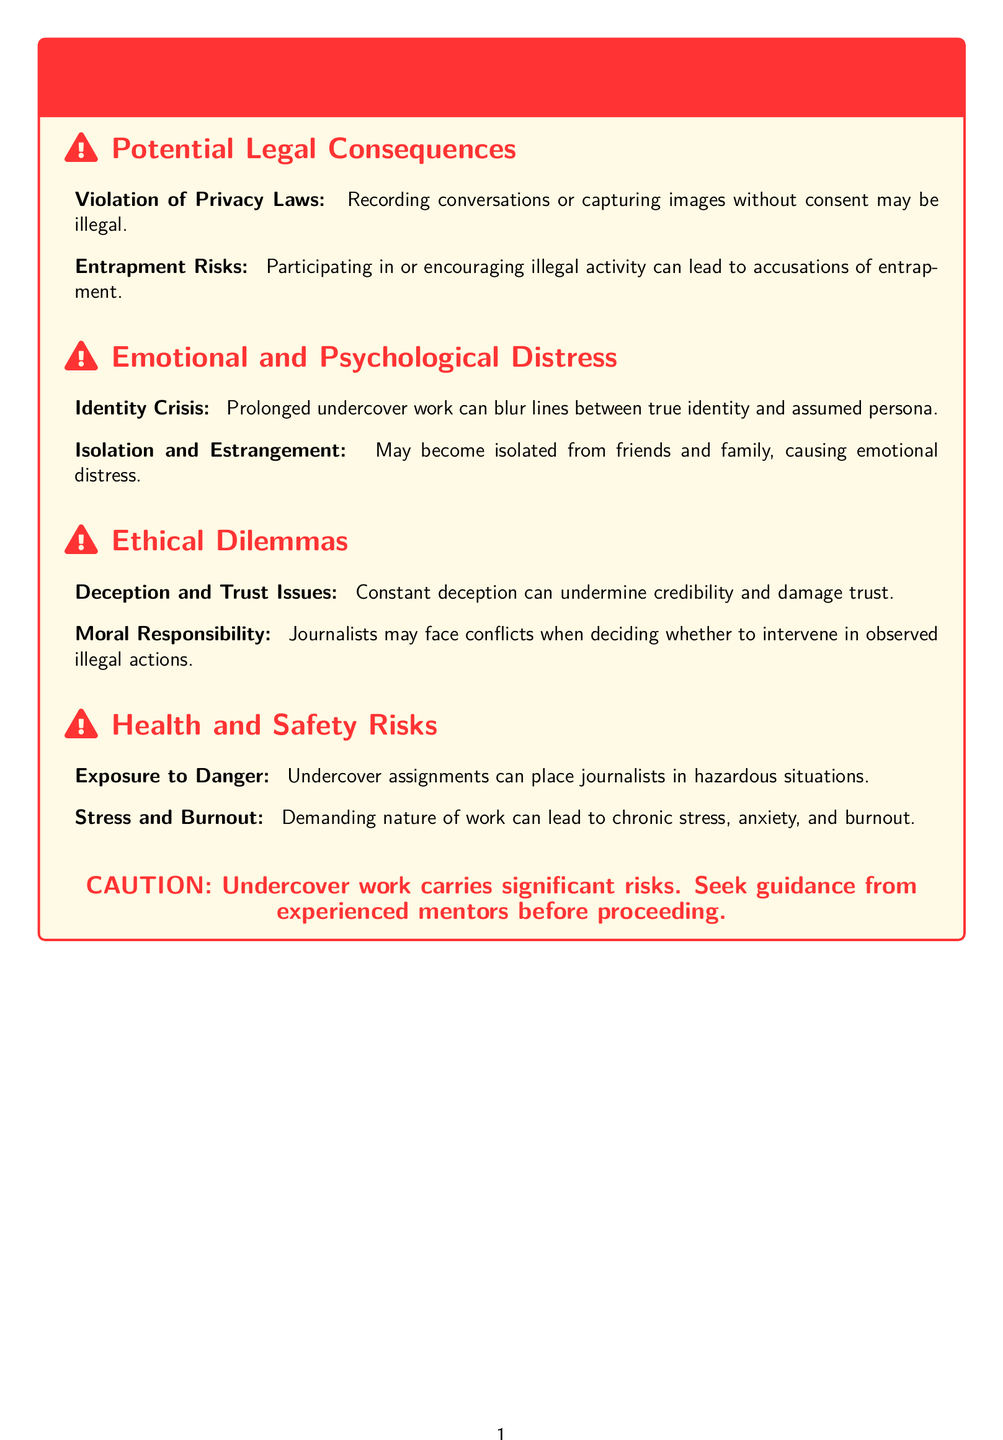What are the potential legal consequences listed? The document lists potential legal consequences including violation of privacy laws and entrapment risks.
Answer: Violation of Privacy Laws, Entrapment Risks What can prolonged undercover work cause? The document states that prolonged undercover work can lead to an identity crisis.
Answer: Identity Crisis What ethical dilemma is mentioned regarding trust? The document highlights deception and trust issues as an ethical dilemma.
Answer: Deception and Trust Issues What is a health risk associated with undercover work? The document specifies exposure to danger as a health risk of undercover work.
Answer: Exposure to Danger How should aspiring investigative journalists proceed according to the caution? The document advises seeking guidance from experienced mentors before proceeding.
Answer: Seek guidance from experienced mentors What is one emotional impact of undercover work? The document mentions isolation and estrangement as an emotional impact.
Answer: Isolation and Estrangement What color is used for caution in the document? The document uses the color red for caution indicators.
Answer: Red How many sections are there in the warning label? The document contains four main sections: Legal Consequences, Emotional and Psychological Distress, Ethical Dilemmas, and Health and Safety Risks.
Answer: Four What does the warning label suggest about the risks of undercover work? The document states that undercover work carries significant risks.
Answer: Significant risks 